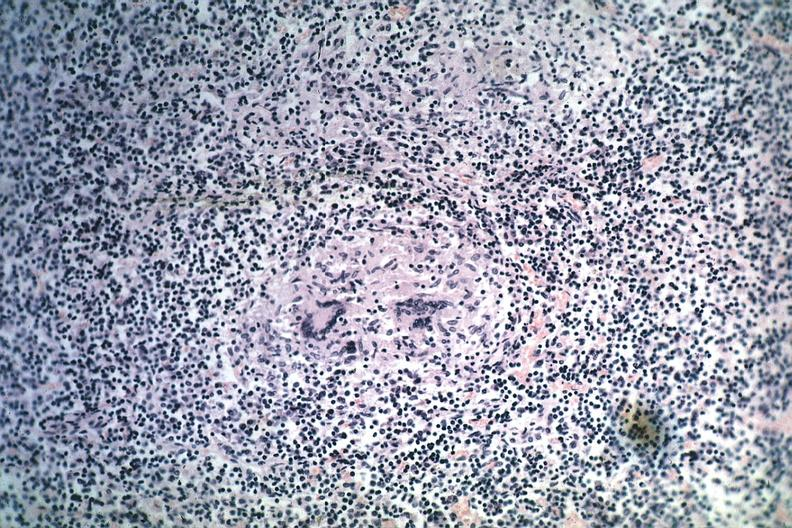does this image show granuloma with minimal necrosis source unknown?
Answer the question using a single word or phrase. Yes 